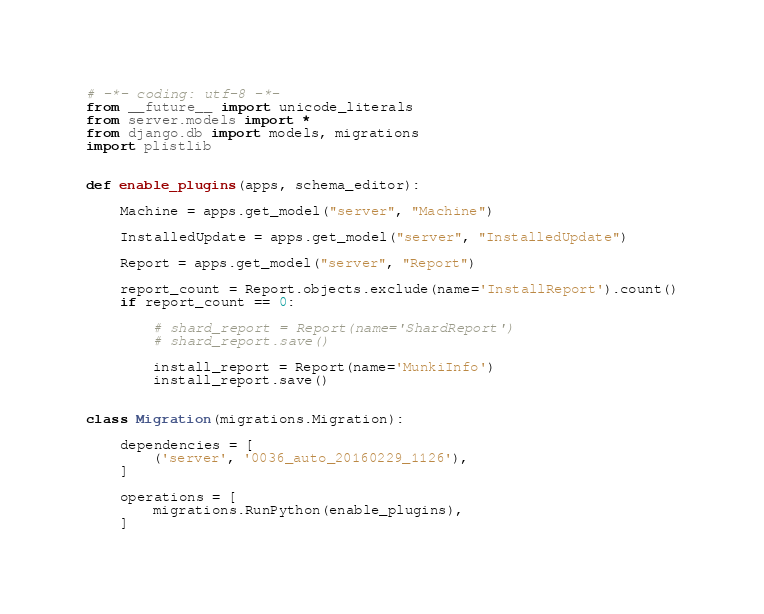<code> <loc_0><loc_0><loc_500><loc_500><_Python_># -*- coding: utf-8 -*-
from __future__ import unicode_literals
from server.models import *
from django.db import models, migrations
import plistlib


def enable_plugins(apps, schema_editor):

    Machine = apps.get_model("server", "Machine")

    InstalledUpdate = apps.get_model("server", "InstalledUpdate")

    Report = apps.get_model("server", "Report")

    report_count = Report.objects.exclude(name='InstallReport').count()
    if report_count == 0:

        # shard_report = Report(name='ShardReport')
        # shard_report.save()

        install_report = Report(name='MunkiInfo')
        install_report.save()


class Migration(migrations.Migration):

    dependencies = [
        ('server', '0036_auto_20160229_1126'),
    ]

    operations = [
        migrations.RunPython(enable_plugins),
    ]
</code> 